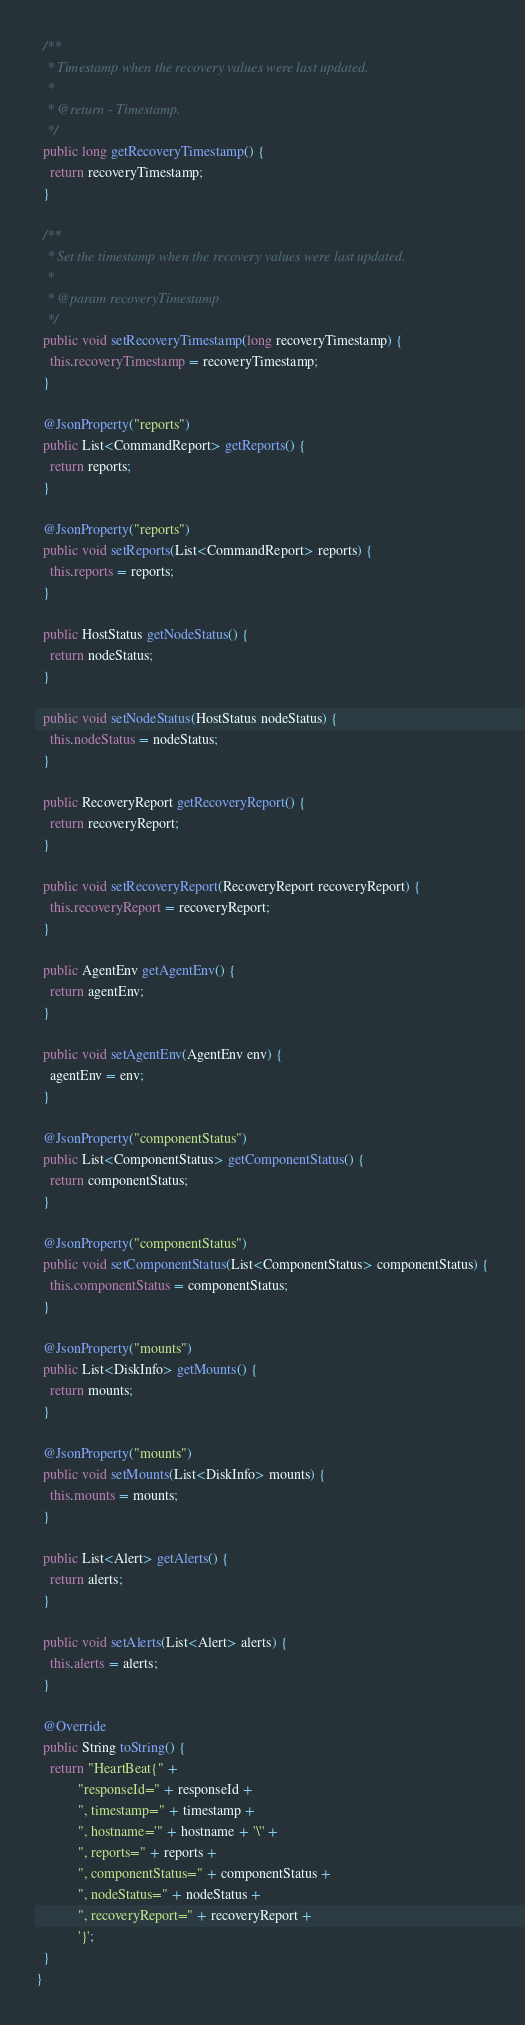Convert code to text. <code><loc_0><loc_0><loc_500><loc_500><_Java_>
  /**
   * Timestamp when the recovery values were last updated.
   *
   * @return - Timestamp.
   */
  public long getRecoveryTimestamp() {
    return recoveryTimestamp;
  }

  /**
   * Set the timestamp when the recovery values were last updated.
   *
   * @param recoveryTimestamp
   */
  public void setRecoveryTimestamp(long recoveryTimestamp) {
    this.recoveryTimestamp = recoveryTimestamp;
  }

  @JsonProperty("reports")
  public List<CommandReport> getReports() {
    return reports;
  }

  @JsonProperty("reports")
  public void setReports(List<CommandReport> reports) {
    this.reports = reports;
  }

  public HostStatus getNodeStatus() {
    return nodeStatus;
  }

  public void setNodeStatus(HostStatus nodeStatus) {
    this.nodeStatus = nodeStatus;
  }

  public RecoveryReport getRecoveryReport() {
    return recoveryReport;
  }

  public void setRecoveryReport(RecoveryReport recoveryReport) {
    this.recoveryReport = recoveryReport;
  }

  public AgentEnv getAgentEnv() {
    return agentEnv;
  }

  public void setAgentEnv(AgentEnv env) {
    agentEnv = env;
  }

  @JsonProperty("componentStatus")
  public List<ComponentStatus> getComponentStatus() {
    return componentStatus;
  }

  @JsonProperty("componentStatus")
  public void setComponentStatus(List<ComponentStatus> componentStatus) {
    this.componentStatus = componentStatus;
  }

  @JsonProperty("mounts")
  public List<DiskInfo> getMounts() {
    return mounts;
  }

  @JsonProperty("mounts")
  public void setMounts(List<DiskInfo> mounts) {
    this.mounts = mounts;
  }

  public List<Alert> getAlerts() {
    return alerts;
  }

  public void setAlerts(List<Alert> alerts) {
    this.alerts = alerts;
  }

  @Override
  public String toString() {
    return "HeartBeat{" +
            "responseId=" + responseId +
            ", timestamp=" + timestamp +
            ", hostname='" + hostname + '\'' +
            ", reports=" + reports +
            ", componentStatus=" + componentStatus +
            ", nodeStatus=" + nodeStatus +
            ", recoveryReport=" + recoveryReport +
            '}';
  }
}
</code> 